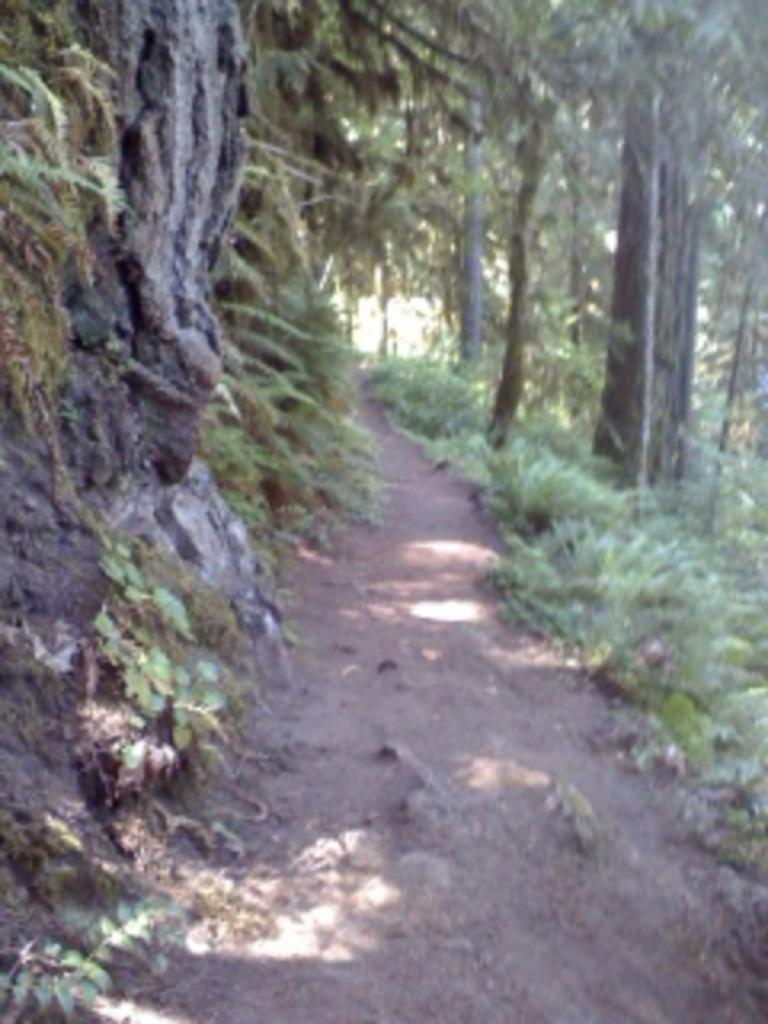What is the main subject of the image? The main subject of the image is a way. What can be seen on one side of the way? There are plants on one side of the way. What can be seen on the other side of the way? There are trees on the other side of the way. What type of string is hanging from the shelf in the image? There is no shelf or string present in the image. 